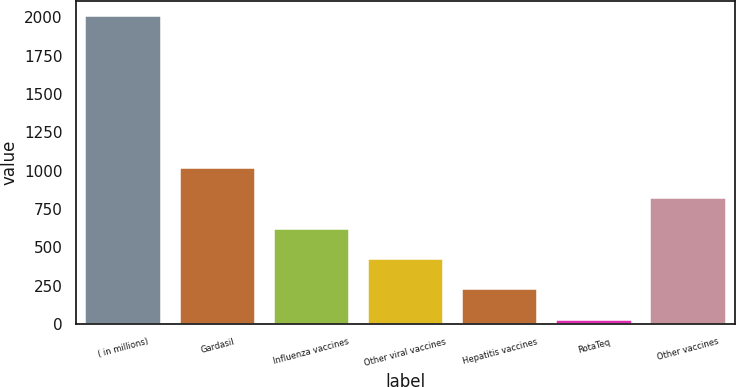Convert chart. <chart><loc_0><loc_0><loc_500><loc_500><bar_chart><fcel>( in millions)<fcel>Gardasil<fcel>Influenza vaccines<fcel>Other viral vaccines<fcel>Hepatitis vaccines<fcel>RotaTeq<fcel>Other vaccines<nl><fcel>2008<fcel>1018.2<fcel>622.28<fcel>424.32<fcel>226.36<fcel>28.4<fcel>820.24<nl></chart> 